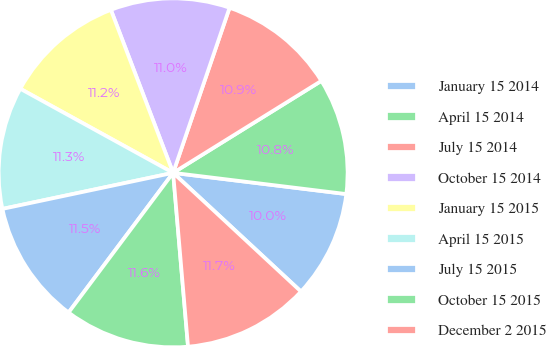Convert chart. <chart><loc_0><loc_0><loc_500><loc_500><pie_chart><fcel>January 15 2014<fcel>April 15 2014<fcel>July 15 2014<fcel>October 15 2014<fcel>January 15 2015<fcel>April 15 2015<fcel>July 15 2015<fcel>October 15 2015<fcel>December 2 2015<nl><fcel>9.97%<fcel>10.78%<fcel>10.92%<fcel>11.05%<fcel>11.19%<fcel>11.32%<fcel>11.46%<fcel>11.59%<fcel>11.73%<nl></chart> 